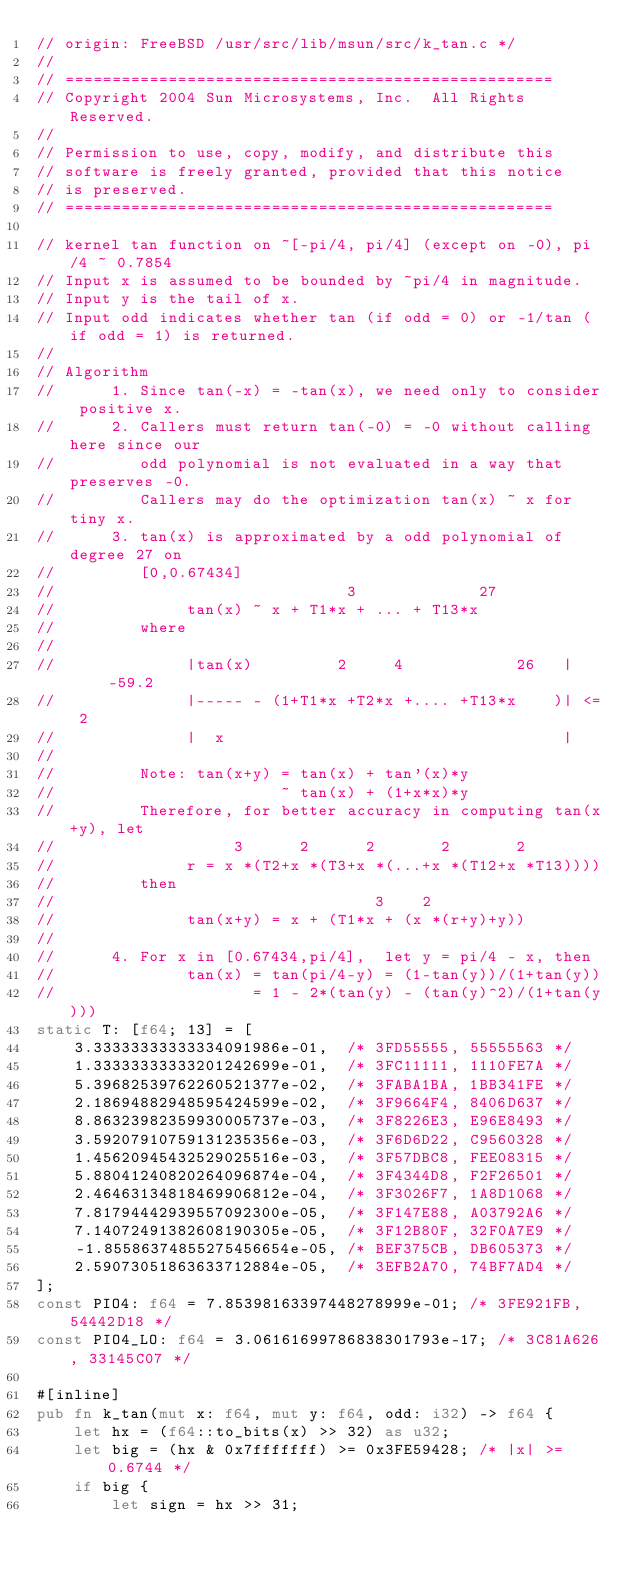<code> <loc_0><loc_0><loc_500><loc_500><_Rust_>// origin: FreeBSD /usr/src/lib/msun/src/k_tan.c */
//
// ====================================================
// Copyright 2004 Sun Microsystems, Inc.  All Rights Reserved.
//
// Permission to use, copy, modify, and distribute this
// software is freely granted, provided that this notice
// is preserved.
// ====================================================

// kernel tan function on ~[-pi/4, pi/4] (except on -0), pi/4 ~ 0.7854
// Input x is assumed to be bounded by ~pi/4 in magnitude.
// Input y is the tail of x.
// Input odd indicates whether tan (if odd = 0) or -1/tan (if odd = 1) is returned.
//
// Algorithm
//      1. Since tan(-x) = -tan(x), we need only to consider positive x.
//      2. Callers must return tan(-0) = -0 without calling here since our
//         odd polynomial is not evaluated in a way that preserves -0.
//         Callers may do the optimization tan(x) ~ x for tiny x.
//      3. tan(x) is approximated by a odd polynomial of degree 27 on
//         [0,0.67434]
//                               3             27
//              tan(x) ~ x + T1*x + ... + T13*x
//         where
//
//              |tan(x)         2     4            26   |     -59.2
//              |----- - (1+T1*x +T2*x +.... +T13*x    )| <= 2
//              |  x                                    |
//
//         Note: tan(x+y) = tan(x) + tan'(x)*y
//                        ~ tan(x) + (1+x*x)*y
//         Therefore, for better accuracy in computing tan(x+y), let
//                   3      2      2       2       2
//              r = x *(T2+x *(T3+x *(...+x *(T12+x *T13))))
//         then
//                                  3    2
//              tan(x+y) = x + (T1*x + (x *(r+y)+y))
//
//      4. For x in [0.67434,pi/4],  let y = pi/4 - x, then
//              tan(x) = tan(pi/4-y) = (1-tan(y))/(1+tan(y))
//                     = 1 - 2*(tan(y) - (tan(y)^2)/(1+tan(y)))
static T: [f64; 13] = [
    3.33333333333334091986e-01,  /* 3FD55555, 55555563 */
    1.33333333333201242699e-01,  /* 3FC11111, 1110FE7A */
    5.39682539762260521377e-02,  /* 3FABA1BA, 1BB341FE */
    2.18694882948595424599e-02,  /* 3F9664F4, 8406D637 */
    8.86323982359930005737e-03,  /* 3F8226E3, E96E8493 */
    3.59207910759131235356e-03,  /* 3F6D6D22, C9560328 */
    1.45620945432529025516e-03,  /* 3F57DBC8, FEE08315 */
    5.88041240820264096874e-04,  /* 3F4344D8, F2F26501 */
    2.46463134818469906812e-04,  /* 3F3026F7, 1A8D1068 */
    7.81794442939557092300e-05,  /* 3F147E88, A03792A6 */
    7.14072491382608190305e-05,  /* 3F12B80F, 32F0A7E9 */
    -1.85586374855275456654e-05, /* BEF375CB, DB605373 */
    2.59073051863633712884e-05,  /* 3EFB2A70, 74BF7AD4 */
];
const PIO4: f64 = 7.85398163397448278999e-01; /* 3FE921FB, 54442D18 */
const PIO4_LO: f64 = 3.06161699786838301793e-17; /* 3C81A626, 33145C07 */

#[inline]
pub fn k_tan(mut x: f64, mut y: f64, odd: i32) -> f64 {
    let hx = (f64::to_bits(x) >> 32) as u32;
    let big = (hx & 0x7fffffff) >= 0x3FE59428; /* |x| >= 0.6744 */
    if big {
        let sign = hx >> 31;</code> 